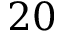Convert formula to latex. <formula><loc_0><loc_0><loc_500><loc_500>2 0</formula> 